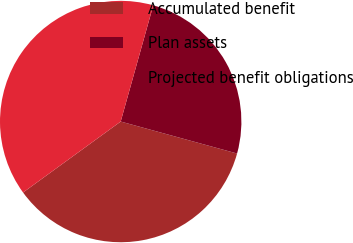Convert chart. <chart><loc_0><loc_0><loc_500><loc_500><pie_chart><fcel>Accumulated benefit<fcel>Plan assets<fcel>Projected benefit obligations<nl><fcel>35.73%<fcel>24.92%<fcel>39.35%<nl></chart> 